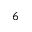<formula> <loc_0><loc_0><loc_500><loc_500>6</formula> 